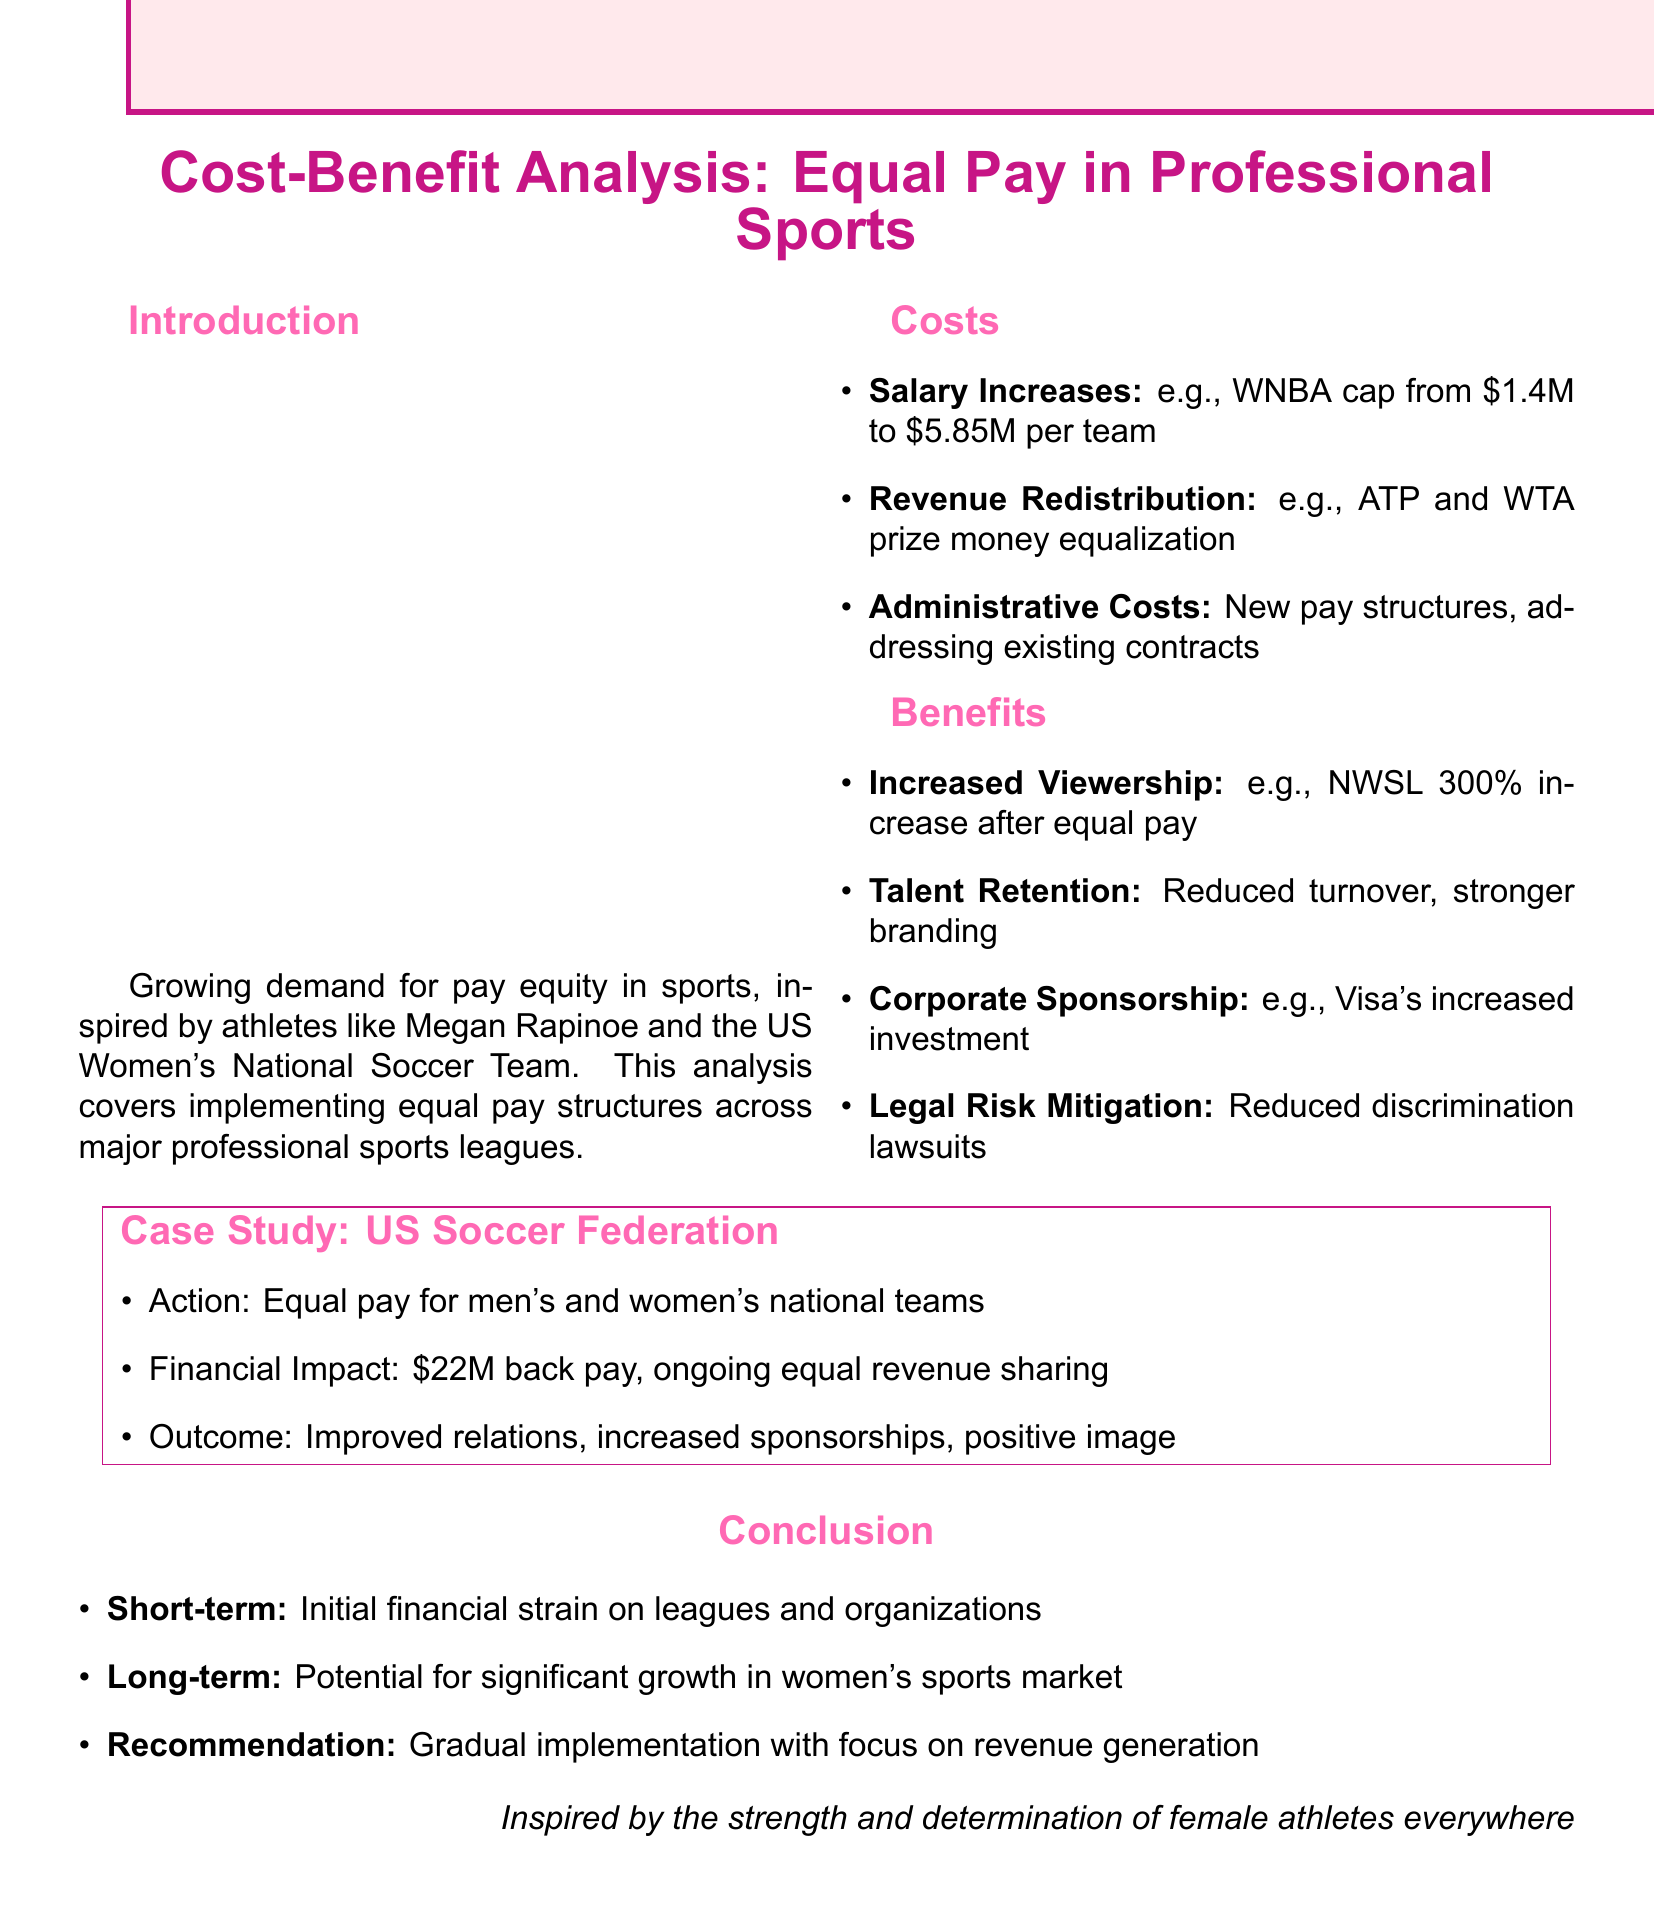What is the title of the document? The title of the document is clearly stated at the beginning.
Answer: Cost-Benefit Analysis: Equal Pay in Professional Sports What is the initial salary cap for the WNBA mentioned in the report? The report details the previous salary cap for the WNBA before the increase.
Answer: $1.4 million What percentage increase in viewership did the NWSL experience after the equal pay agreement? The document provides a specific percentage increase in viewership for the NWSL.
Answer: 300% How much back pay did the US Soccer Federation implement for its equal pay structure? The report specifies the amount of back pay required for equal pay implementation by the US Soccer Federation.
Answer: $22 million What is one category of costs associated with implementing equal pay structures? The report lists various costs associated with equal pay; one category is specifically highlighted.
Answer: Salary Increases What long-term potential benefit is discussed for women's sports? The conclusion section addresses the long-term impact of equal pay on women’s sports specifically.
Answer: Growth in women's sports market What corporate sponsor increased investment following equal pay initiatives? The document names a significant corporate sponsor that invested more in women's soccer after equal pay efforts were made.
Answer: Visa What is the recommended approach for implementing equal pay structures? The recommendation section outlines the advised strategy for implementing equal pay.
Answer: Gradual implementation with focus on revenue generation 